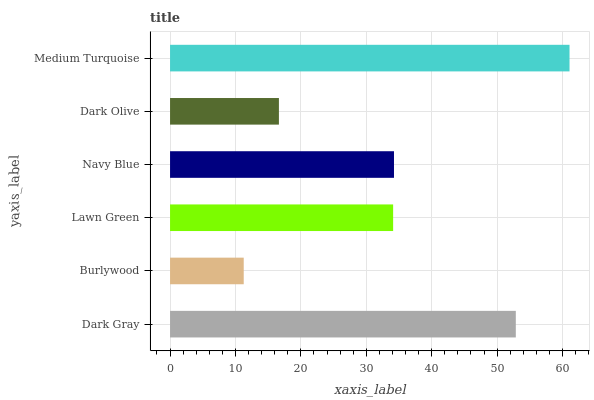Is Burlywood the minimum?
Answer yes or no. Yes. Is Medium Turquoise the maximum?
Answer yes or no. Yes. Is Lawn Green the minimum?
Answer yes or no. No. Is Lawn Green the maximum?
Answer yes or no. No. Is Lawn Green greater than Burlywood?
Answer yes or no. Yes. Is Burlywood less than Lawn Green?
Answer yes or no. Yes. Is Burlywood greater than Lawn Green?
Answer yes or no. No. Is Lawn Green less than Burlywood?
Answer yes or no. No. Is Navy Blue the high median?
Answer yes or no. Yes. Is Lawn Green the low median?
Answer yes or no. Yes. Is Medium Turquoise the high median?
Answer yes or no. No. Is Medium Turquoise the low median?
Answer yes or no. No. 